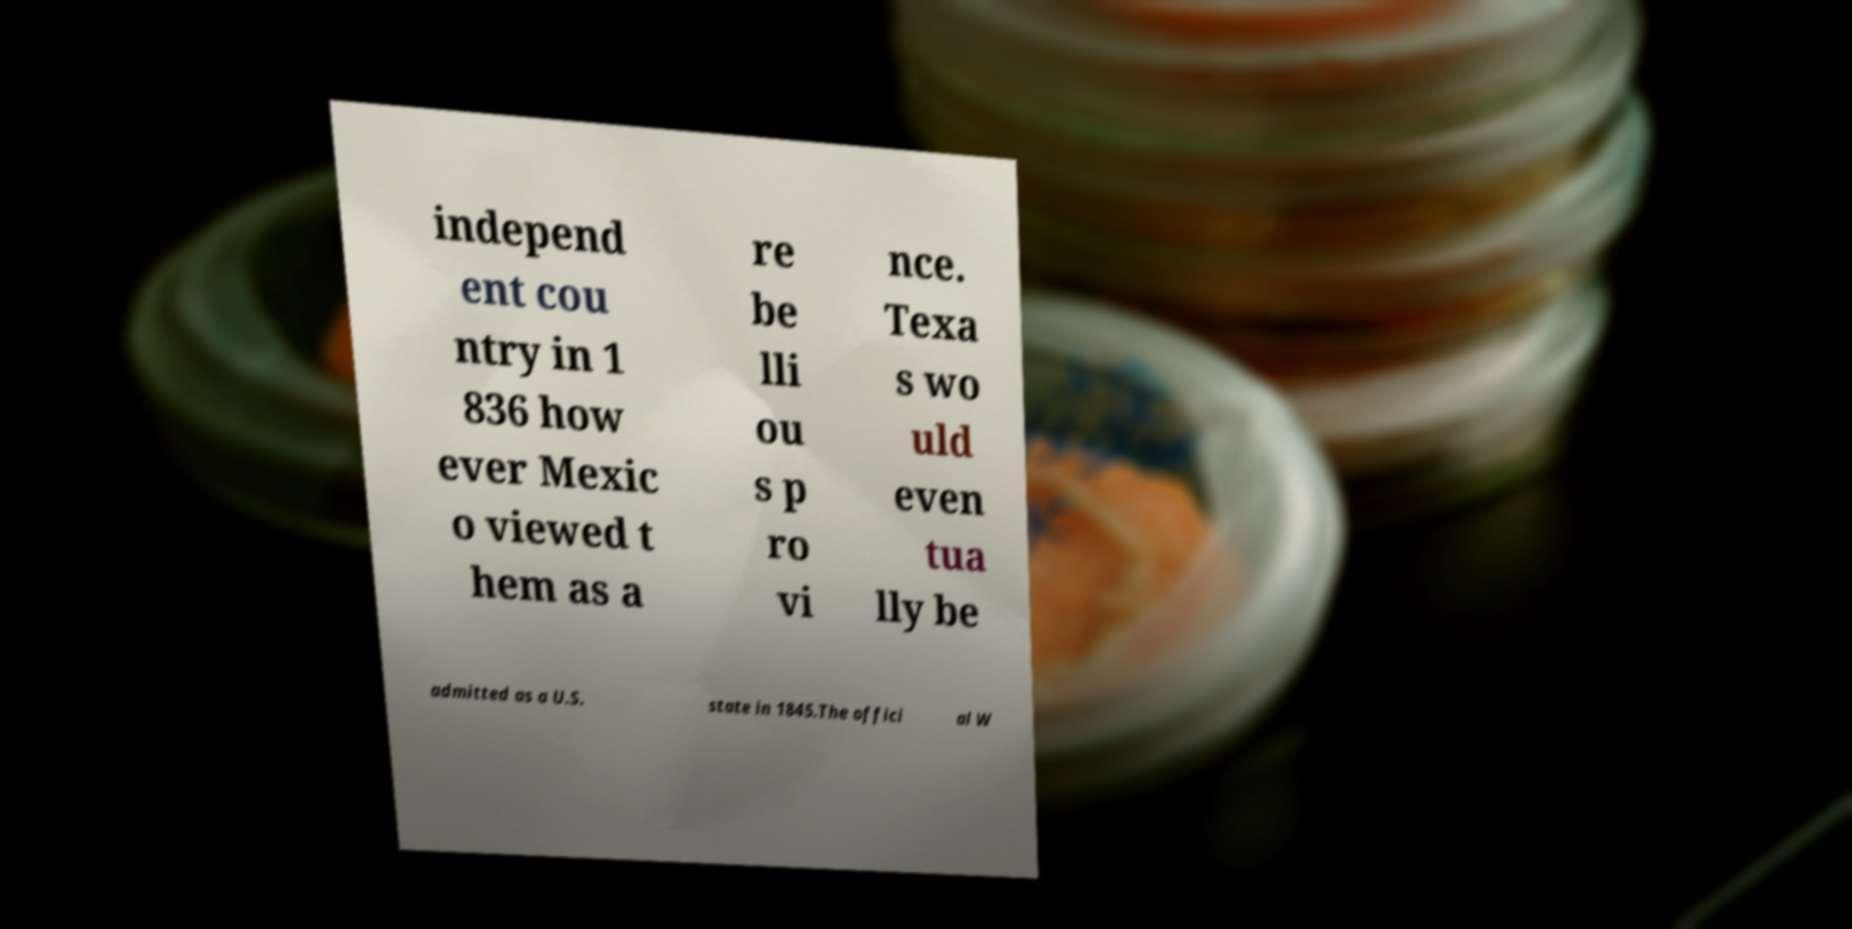There's text embedded in this image that I need extracted. Can you transcribe it verbatim? independ ent cou ntry in 1 836 how ever Mexic o viewed t hem as a re be lli ou s p ro vi nce. Texa s wo uld even tua lly be admitted as a U.S. state in 1845.The offici al W 